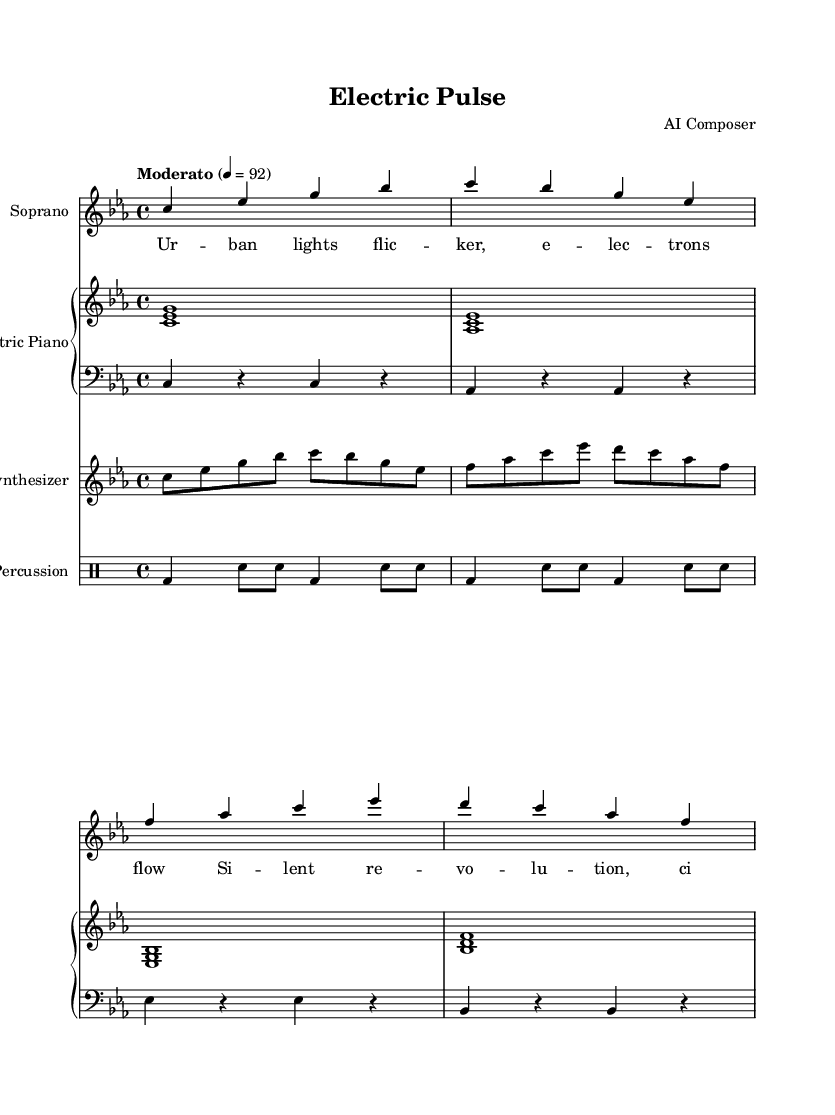What is the key signature of this music? The key signature is indicated at the beginning of the sheet music. In this case, it shows three flats, which corresponds to C minor.
Answer: C minor What is the time signature of this piece? The time signature is displayed at the beginning of the score, which is noted as 4/4, indicating four beats in a measure.
Answer: 4/4 What is the tempo marking given for this score? The tempo marking is written in the instructions below the title of the piece, indicating that the music should be played at a speed marked as "Moderato" at 92 beats per minute.
Answer: Moderato How many voices are present in the soprano section? By examining the soprano part, there are 4 main notes in the measure, indicating the presence of single melodic line. This confirms the presence of one voice in the soprano section.
Answer: One voice What type of instruments are featured in the score besides the soprano? The score indicates various instruments, and by examining the notation, we see that there is an Electric Piano, Synthesizer, and Percussion included.
Answer: Electric Piano, Synthesizer, Percussion What theme is reflected in the lyrics of the soprano part? Looking at the lyrics, they express ideas related to urban life and electronic transformation, highlighting the cultural shifts due to urban electrification.
Answer: Urban electrification 